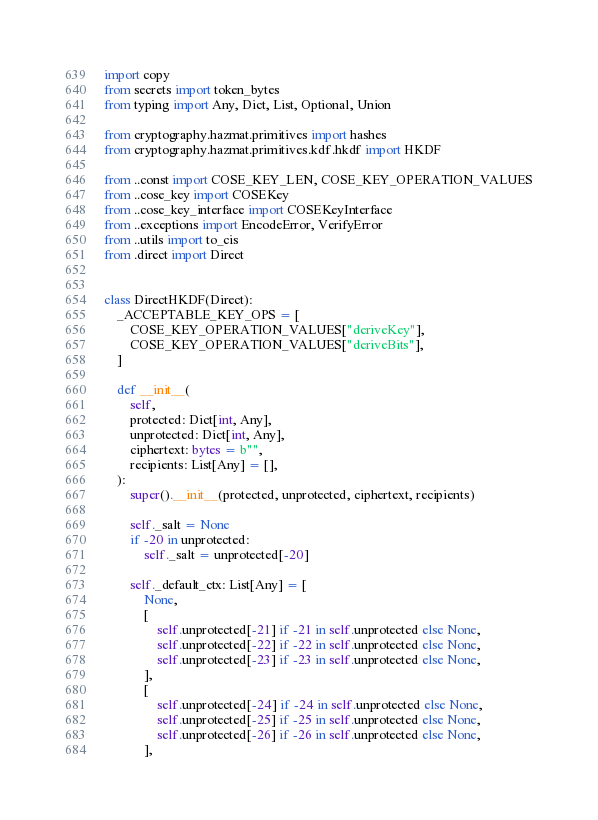Convert code to text. <code><loc_0><loc_0><loc_500><loc_500><_Python_>import copy
from secrets import token_bytes
from typing import Any, Dict, List, Optional, Union

from cryptography.hazmat.primitives import hashes
from cryptography.hazmat.primitives.kdf.hkdf import HKDF

from ..const import COSE_KEY_LEN, COSE_KEY_OPERATION_VALUES
from ..cose_key import COSEKey
from ..cose_key_interface import COSEKeyInterface
from ..exceptions import EncodeError, VerifyError
from ..utils import to_cis
from .direct import Direct


class DirectHKDF(Direct):
    _ACCEPTABLE_KEY_OPS = [
        COSE_KEY_OPERATION_VALUES["deriveKey"],
        COSE_KEY_OPERATION_VALUES["deriveBits"],
    ]

    def __init__(
        self,
        protected: Dict[int, Any],
        unprotected: Dict[int, Any],
        ciphertext: bytes = b"",
        recipients: List[Any] = [],
    ):
        super().__init__(protected, unprotected, ciphertext, recipients)

        self._salt = None
        if -20 in unprotected:
            self._salt = unprotected[-20]

        self._default_ctx: List[Any] = [
            None,
            [
                self.unprotected[-21] if -21 in self.unprotected else None,
                self.unprotected[-22] if -22 in self.unprotected else None,
                self.unprotected[-23] if -23 in self.unprotected else None,
            ],
            [
                self.unprotected[-24] if -24 in self.unprotected else None,
                self.unprotected[-25] if -25 in self.unprotected else None,
                self.unprotected[-26] if -26 in self.unprotected else None,
            ],</code> 